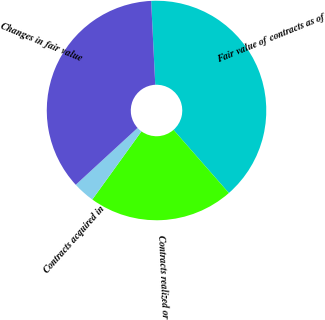Convert chart. <chart><loc_0><loc_0><loc_500><loc_500><pie_chart><fcel>Fair value of contracts as of<fcel>Contracts realized or<fcel>Contracts acquired in<fcel>Changes in fair value<nl><fcel>39.33%<fcel>21.4%<fcel>3.22%<fcel>36.05%<nl></chart> 